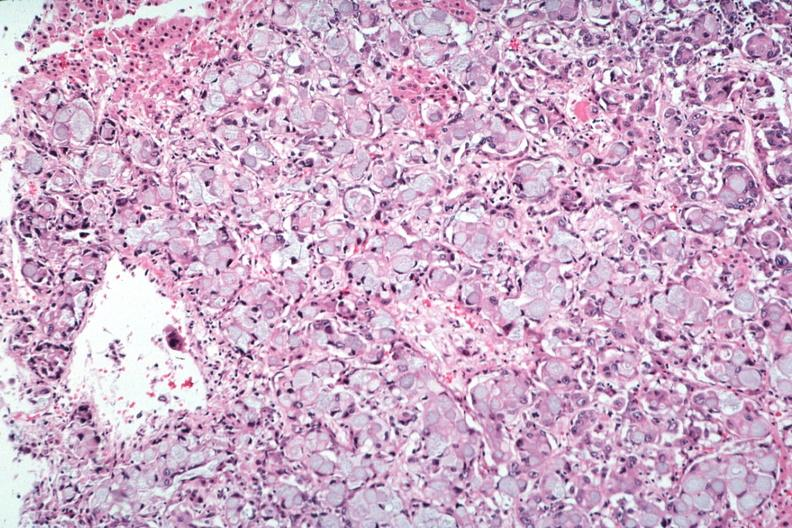what is present?
Answer the question using a single word or phrase. Endocrine 